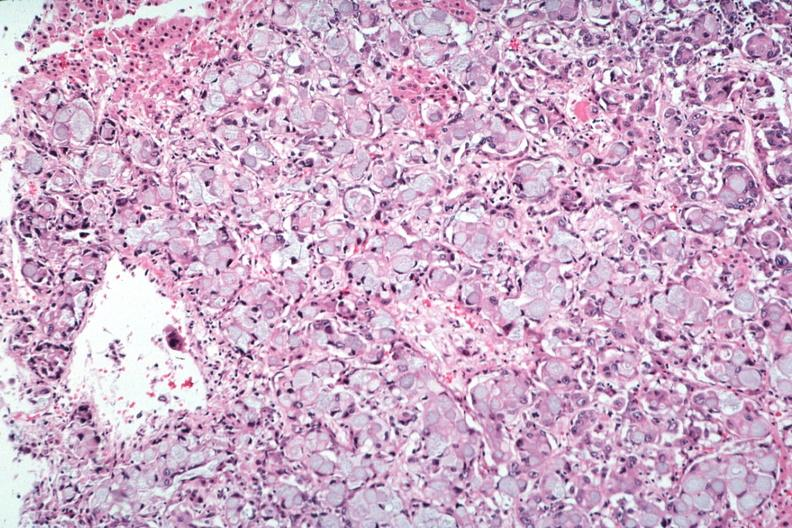what is present?
Answer the question using a single word or phrase. Endocrine 